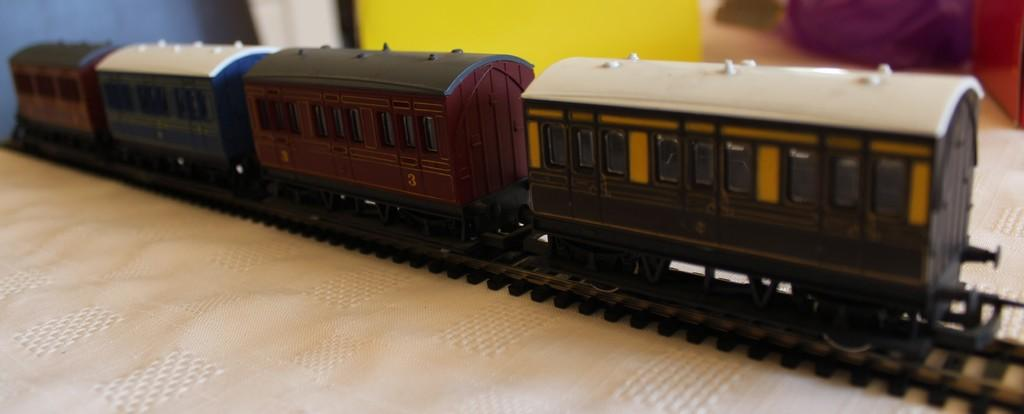What is the main subject of the image? The main subject of the image is a toy train. What is the toy train doing in the image? The toy train is on a track. What is the track placed on in the image? The track is on a cloth. What type of art can be seen hanging on the wall in the image? There is no art or wall present in the image; it features a toy train on a track on a cloth. What type of corn is visible in the image? There is no corn present in the image. 